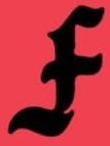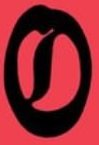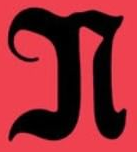What words are shown in these images in order, separated by a semicolon? F; O; N 